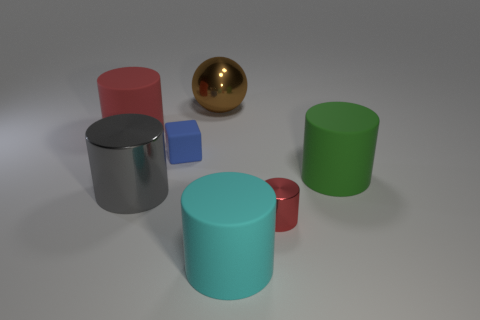There is another thing that is the same color as the small metallic thing; what material is it?
Your answer should be very brief. Rubber. How many big rubber cylinders are both behind the big metal cylinder and in front of the big gray object?
Offer a terse response. 0. What is the red cylinder that is in front of the shiny cylinder on the left side of the large brown object made of?
Your answer should be compact. Metal. Are there any small cylinders that have the same material as the cyan object?
Offer a terse response. No. What material is the brown object that is the same size as the cyan matte thing?
Your answer should be very brief. Metal. There is a cylinder that is on the right side of the metallic object on the right side of the rubber cylinder that is in front of the gray cylinder; what is its size?
Ensure brevity in your answer.  Large. Is there a large red thing that is to the left of the red cylinder behind the green object?
Give a very brief answer. No. There is a tiny metallic thing; does it have the same shape as the small thing left of the big metal ball?
Your answer should be compact. No. There is a big metal object that is behind the large green thing; what color is it?
Provide a succinct answer. Brown. How big is the metal cylinder that is right of the cyan cylinder on the right side of the small blue block?
Give a very brief answer. Small. 